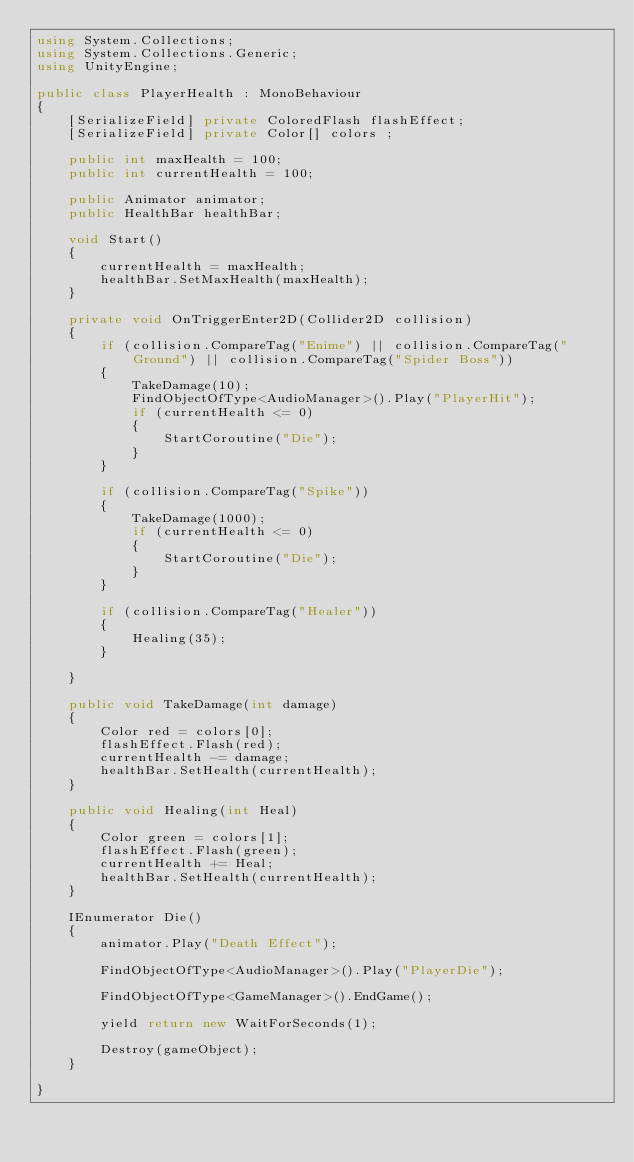Convert code to text. <code><loc_0><loc_0><loc_500><loc_500><_C#_>using System.Collections;
using System.Collections.Generic;
using UnityEngine;

public class PlayerHealth : MonoBehaviour
{
    [SerializeField] private ColoredFlash flashEffect;
    [SerializeField] private Color[] colors ;

    public int maxHealth = 100;
    public int currentHealth = 100;

    public Animator animator;
    public HealthBar healthBar;

    void Start()
    {
        currentHealth = maxHealth;
        healthBar.SetMaxHealth(maxHealth);
    }

    private void OnTriggerEnter2D(Collider2D collision)
    {
        if (collision.CompareTag("Enime") || collision.CompareTag("Ground") || collision.CompareTag("Spider Boss"))
        {
            TakeDamage(10);
            FindObjectOfType<AudioManager>().Play("PlayerHit");
            if (currentHealth <= 0)
            {
                StartCoroutine("Die");
            }
        }

        if (collision.CompareTag("Spike"))
        {
            TakeDamage(1000);
            if (currentHealth <= 0)
            {
                StartCoroutine("Die");
            }
        }

        if (collision.CompareTag("Healer"))
        {
            Healing(35);
        }

    }

    public void TakeDamage(int damage)
    {
        Color red = colors[0];
        flashEffect.Flash(red);
        currentHealth -= damage;
        healthBar.SetHealth(currentHealth);
    }

    public void Healing(int Heal)
    {
        Color green = colors[1];
        flashEffect.Flash(green);
        currentHealth += Heal;
        healthBar.SetHealth(currentHealth);
    }

    IEnumerator Die()
    {
        animator.Play("Death Effect");

        FindObjectOfType<AudioManager>().Play("PlayerDie");

        FindObjectOfType<GameManager>().EndGame();

        yield return new WaitForSeconds(1);

        Destroy(gameObject);
    }

}
</code> 